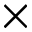Convert formula to latex. <formula><loc_0><loc_0><loc_500><loc_500>\times</formula> 